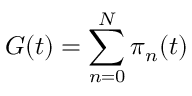Convert formula to latex. <formula><loc_0><loc_0><loc_500><loc_500>G ( t ) = \sum _ { n = 0 } ^ { N } \pi _ { n } ( t )</formula> 